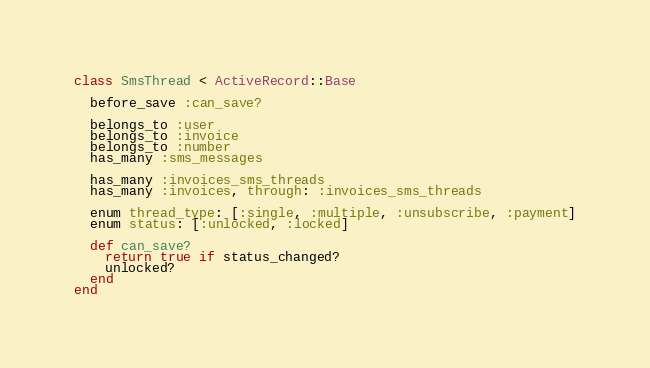<code> <loc_0><loc_0><loc_500><loc_500><_Ruby_>class SmsThread < ActiveRecord::Base

  before_save :can_save?

  belongs_to :user
  belongs_to :invoice
  belongs_to :number
  has_many :sms_messages

  has_many :invoices_sms_threads
  has_many :invoices, through: :invoices_sms_threads

  enum thread_type: [:single, :multiple, :unsubscribe, :payment]
  enum status: [:unlocked, :locked]

  def can_save?
    return true if status_changed?
    unlocked?
  end
end
</code> 